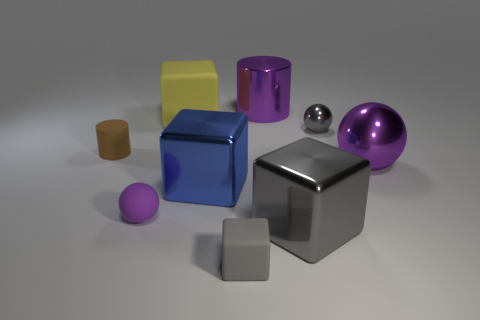How many small balls are the same color as the small rubber cube?
Ensure brevity in your answer.  1. There is a large thing that is the same color as the big ball; what material is it?
Provide a short and direct response. Metal. What material is the big thing that is the same shape as the tiny brown thing?
Ensure brevity in your answer.  Metal. How many big red metal cylinders are there?
Keep it short and to the point. 0. There is a large shiny thing that is behind the big ball; what shape is it?
Keep it short and to the point. Cylinder. What is the color of the metallic object that is in front of the tiny sphere that is in front of the blue metallic object in front of the yellow thing?
Provide a succinct answer. Gray. There is a small brown thing that is made of the same material as the big yellow block; what is its shape?
Your response must be concise. Cylinder. Are there fewer tiny green matte cylinders than big balls?
Offer a very short reply. Yes. Is the gray ball made of the same material as the large ball?
Your answer should be compact. Yes. How many other things are there of the same color as the matte sphere?
Offer a very short reply. 2. 